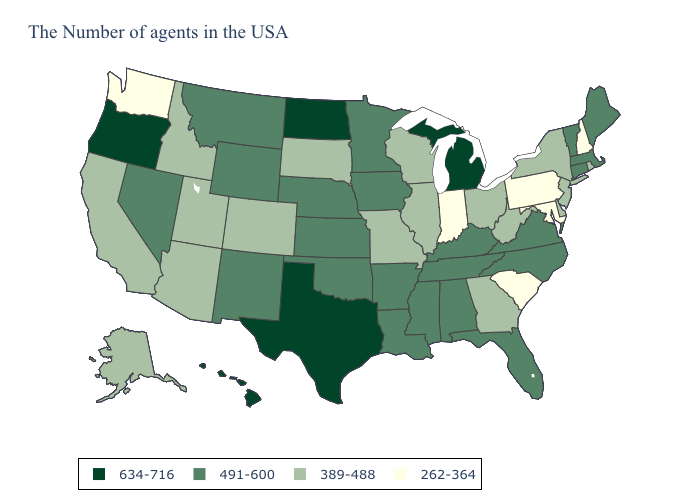What is the value of Mississippi?
Give a very brief answer. 491-600. What is the value of Mississippi?
Keep it brief. 491-600. Name the states that have a value in the range 389-488?
Be succinct. Rhode Island, New York, New Jersey, Delaware, West Virginia, Ohio, Georgia, Wisconsin, Illinois, Missouri, South Dakota, Colorado, Utah, Arizona, Idaho, California, Alaska. Name the states that have a value in the range 634-716?
Concise answer only. Michigan, Texas, North Dakota, Oregon, Hawaii. Among the states that border Wyoming , does Montana have the highest value?
Write a very short answer. Yes. Does Wisconsin have a higher value than Montana?
Answer briefly. No. What is the highest value in the USA?
Quick response, please. 634-716. Which states have the highest value in the USA?
Short answer required. Michigan, Texas, North Dakota, Oregon, Hawaii. What is the value of Rhode Island?
Concise answer only. 389-488. Does Washington have the lowest value in the USA?
Keep it brief. Yes. Name the states that have a value in the range 491-600?
Concise answer only. Maine, Massachusetts, Vermont, Connecticut, Virginia, North Carolina, Florida, Kentucky, Alabama, Tennessee, Mississippi, Louisiana, Arkansas, Minnesota, Iowa, Kansas, Nebraska, Oklahoma, Wyoming, New Mexico, Montana, Nevada. Among the states that border Kansas , which have the lowest value?
Quick response, please. Missouri, Colorado. Does Maryland have the lowest value in the USA?
Keep it brief. Yes. What is the highest value in the USA?
Answer briefly. 634-716. Does the first symbol in the legend represent the smallest category?
Answer briefly. No. 